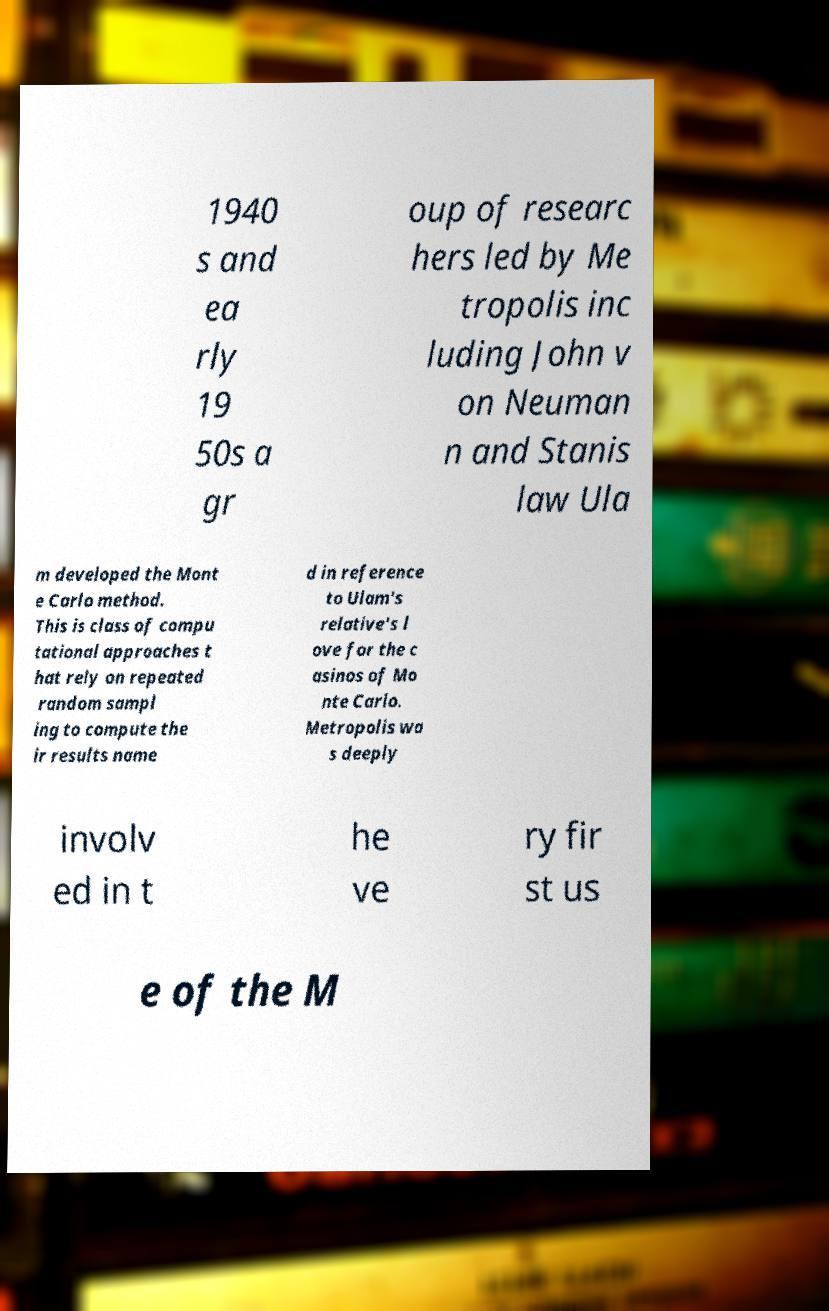Please read and relay the text visible in this image. What does it say? 1940 s and ea rly 19 50s a gr oup of researc hers led by Me tropolis inc luding John v on Neuman n and Stanis law Ula m developed the Mont e Carlo method. This is class of compu tational approaches t hat rely on repeated random sampl ing to compute the ir results name d in reference to Ulam's relative's l ove for the c asinos of Mo nte Carlo. Metropolis wa s deeply involv ed in t he ve ry fir st us e of the M 